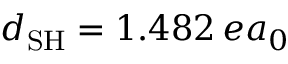<formula> <loc_0><loc_0><loc_500><loc_500>d _ { S H } = 1 . 4 8 2 \, e a _ { 0 }</formula> 